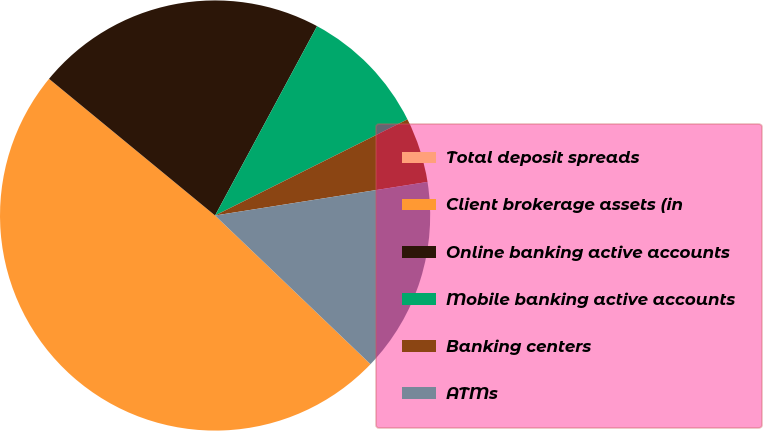Convert chart to OTSL. <chart><loc_0><loc_0><loc_500><loc_500><pie_chart><fcel>Total deposit spreads<fcel>Client brokerage assets (in<fcel>Online banking active accounts<fcel>Mobile banking active accounts<fcel>Banking centers<fcel>ATMs<nl><fcel>0.0%<fcel>48.81%<fcel>21.9%<fcel>9.76%<fcel>4.88%<fcel>14.64%<nl></chart> 